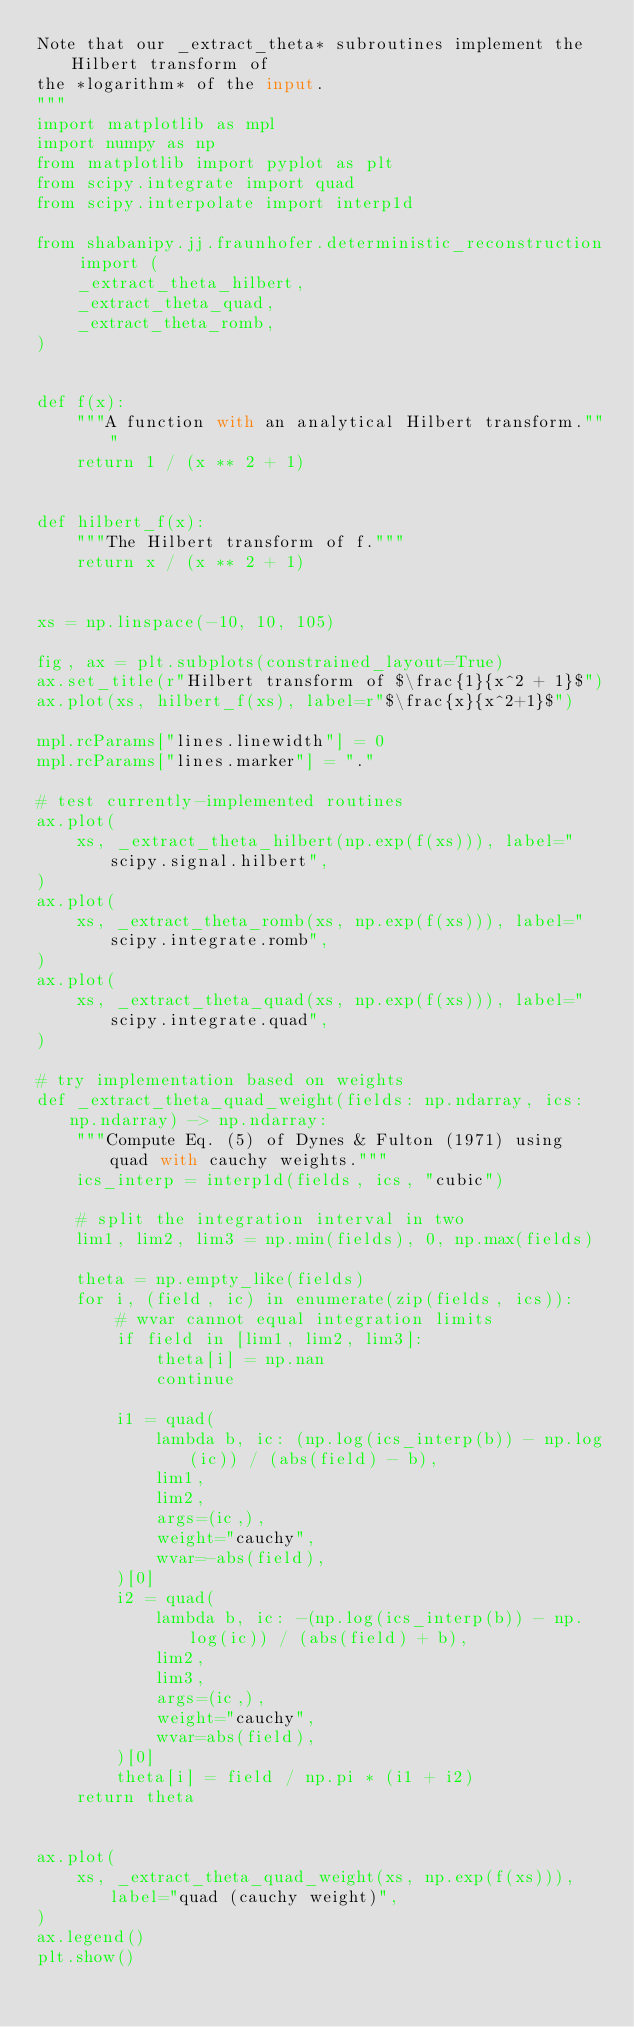<code> <loc_0><loc_0><loc_500><loc_500><_Python_>Note that our _extract_theta* subroutines implement the Hilbert transform of
the *logarithm* of the input.
"""
import matplotlib as mpl
import numpy as np
from matplotlib import pyplot as plt
from scipy.integrate import quad
from scipy.interpolate import interp1d

from shabanipy.jj.fraunhofer.deterministic_reconstruction import (
    _extract_theta_hilbert,
    _extract_theta_quad,
    _extract_theta_romb,
)


def f(x):
    """A function with an analytical Hilbert transform."""
    return 1 / (x ** 2 + 1)


def hilbert_f(x):
    """The Hilbert transform of f."""
    return x / (x ** 2 + 1)


xs = np.linspace(-10, 10, 105)

fig, ax = plt.subplots(constrained_layout=True)
ax.set_title(r"Hilbert transform of $\frac{1}{x^2 + 1}$")
ax.plot(xs, hilbert_f(xs), label=r"$\frac{x}{x^2+1}$")

mpl.rcParams["lines.linewidth"] = 0
mpl.rcParams["lines.marker"] = "."

# test currently-implemented routines
ax.plot(
    xs, _extract_theta_hilbert(np.exp(f(xs))), label="scipy.signal.hilbert",
)
ax.plot(
    xs, _extract_theta_romb(xs, np.exp(f(xs))), label="scipy.integrate.romb",
)
ax.plot(
    xs, _extract_theta_quad(xs, np.exp(f(xs))), label="scipy.integrate.quad",
)

# try implementation based on weights
def _extract_theta_quad_weight(fields: np.ndarray, ics: np.ndarray) -> np.ndarray:
    """Compute Eq. (5) of Dynes & Fulton (1971) using quad with cauchy weights."""
    ics_interp = interp1d(fields, ics, "cubic")

    # split the integration interval in two
    lim1, lim2, lim3 = np.min(fields), 0, np.max(fields)

    theta = np.empty_like(fields)
    for i, (field, ic) in enumerate(zip(fields, ics)):
        # wvar cannot equal integration limits
        if field in [lim1, lim2, lim3]:
            theta[i] = np.nan
            continue

        i1 = quad(
            lambda b, ic: (np.log(ics_interp(b)) - np.log(ic)) / (abs(field) - b),
            lim1,
            lim2,
            args=(ic,),
            weight="cauchy",
            wvar=-abs(field),
        )[0]
        i2 = quad(
            lambda b, ic: -(np.log(ics_interp(b)) - np.log(ic)) / (abs(field) + b),
            lim2,
            lim3,
            args=(ic,),
            weight="cauchy",
            wvar=abs(field),
        )[0]
        theta[i] = field / np.pi * (i1 + i2)
    return theta


ax.plot(
    xs, _extract_theta_quad_weight(xs, np.exp(f(xs))), label="quad (cauchy weight)",
)
ax.legend()
plt.show()
</code> 